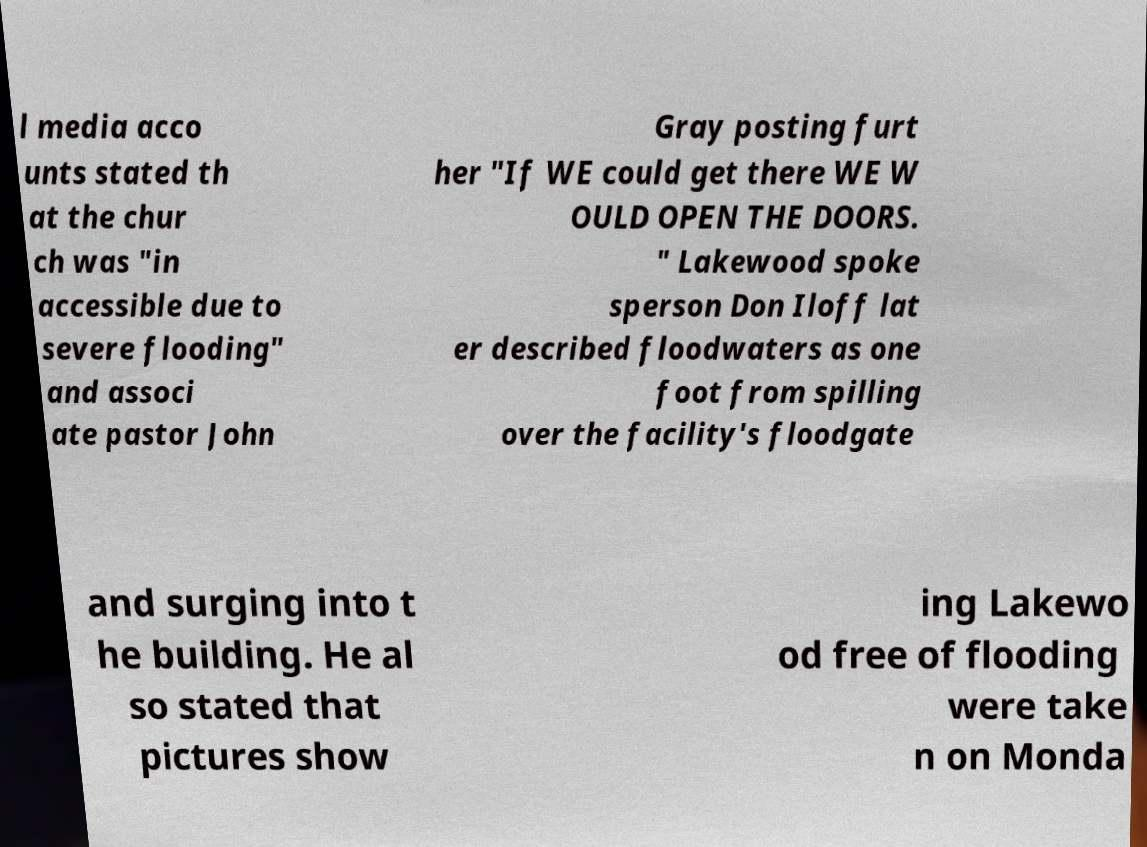I need the written content from this picture converted into text. Can you do that? l media acco unts stated th at the chur ch was "in accessible due to severe flooding" and associ ate pastor John Gray posting furt her "If WE could get there WE W OULD OPEN THE DOORS. " Lakewood spoke sperson Don Iloff lat er described floodwaters as one foot from spilling over the facility's floodgate and surging into t he building. He al so stated that pictures show ing Lakewo od free of flooding were take n on Monda 